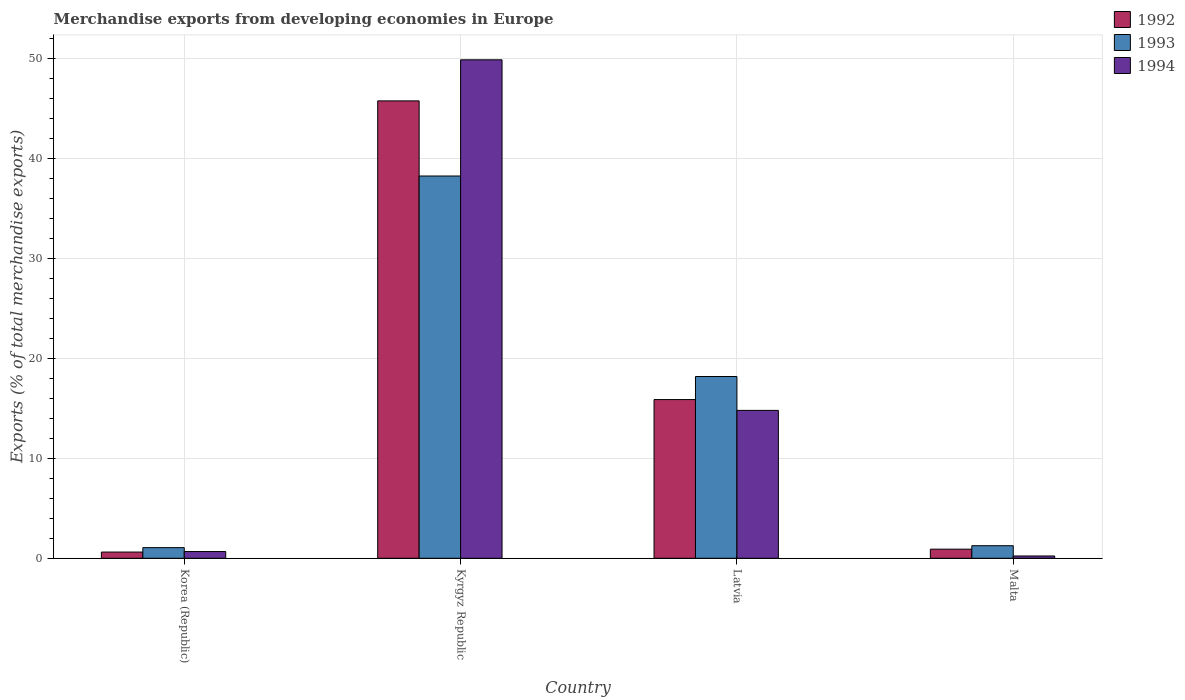How many groups of bars are there?
Make the answer very short. 4. How many bars are there on the 1st tick from the right?
Your answer should be very brief. 3. What is the label of the 4th group of bars from the left?
Offer a very short reply. Malta. In how many cases, is the number of bars for a given country not equal to the number of legend labels?
Your response must be concise. 0. What is the percentage of total merchandise exports in 1992 in Malta?
Keep it short and to the point. 0.91. Across all countries, what is the maximum percentage of total merchandise exports in 1992?
Make the answer very short. 45.73. Across all countries, what is the minimum percentage of total merchandise exports in 1993?
Your answer should be compact. 1.06. In which country was the percentage of total merchandise exports in 1994 maximum?
Make the answer very short. Kyrgyz Republic. What is the total percentage of total merchandise exports in 1994 in the graph?
Provide a short and direct response. 65.52. What is the difference between the percentage of total merchandise exports in 1993 in Kyrgyz Republic and that in Latvia?
Your answer should be compact. 20.04. What is the difference between the percentage of total merchandise exports in 1992 in Kyrgyz Republic and the percentage of total merchandise exports in 1994 in Latvia?
Ensure brevity in your answer.  30.94. What is the average percentage of total merchandise exports in 1994 per country?
Provide a short and direct response. 16.38. What is the difference between the percentage of total merchandise exports of/in 1993 and percentage of total merchandise exports of/in 1992 in Latvia?
Keep it short and to the point. 2.31. What is the ratio of the percentage of total merchandise exports in 1994 in Kyrgyz Republic to that in Malta?
Your answer should be very brief. 217.01. Is the difference between the percentage of total merchandise exports in 1993 in Korea (Republic) and Kyrgyz Republic greater than the difference between the percentage of total merchandise exports in 1992 in Korea (Republic) and Kyrgyz Republic?
Ensure brevity in your answer.  Yes. What is the difference between the highest and the second highest percentage of total merchandise exports in 1992?
Keep it short and to the point. -44.82. What is the difference between the highest and the lowest percentage of total merchandise exports in 1993?
Ensure brevity in your answer.  37.16. In how many countries, is the percentage of total merchandise exports in 1994 greater than the average percentage of total merchandise exports in 1994 taken over all countries?
Your answer should be very brief. 1. Is the sum of the percentage of total merchandise exports in 1993 in Korea (Republic) and Malta greater than the maximum percentage of total merchandise exports in 1992 across all countries?
Provide a short and direct response. No. What does the 1st bar from the left in Kyrgyz Republic represents?
Your response must be concise. 1992. Does the graph contain any zero values?
Offer a terse response. No. Where does the legend appear in the graph?
Keep it short and to the point. Top right. How are the legend labels stacked?
Offer a very short reply. Vertical. What is the title of the graph?
Offer a terse response. Merchandise exports from developing economies in Europe. What is the label or title of the Y-axis?
Provide a succinct answer. Exports (% of total merchandise exports). What is the Exports (% of total merchandise exports) of 1992 in Korea (Republic)?
Provide a succinct answer. 0.62. What is the Exports (% of total merchandise exports) of 1993 in Korea (Republic)?
Make the answer very short. 1.06. What is the Exports (% of total merchandise exports) in 1994 in Korea (Republic)?
Make the answer very short. 0.67. What is the Exports (% of total merchandise exports) in 1992 in Kyrgyz Republic?
Provide a short and direct response. 45.73. What is the Exports (% of total merchandise exports) of 1993 in Kyrgyz Republic?
Your answer should be compact. 38.22. What is the Exports (% of total merchandise exports) in 1994 in Kyrgyz Republic?
Your response must be concise. 49.84. What is the Exports (% of total merchandise exports) in 1992 in Latvia?
Provide a succinct answer. 15.87. What is the Exports (% of total merchandise exports) in 1993 in Latvia?
Give a very brief answer. 18.17. What is the Exports (% of total merchandise exports) of 1994 in Latvia?
Ensure brevity in your answer.  14.79. What is the Exports (% of total merchandise exports) of 1992 in Malta?
Your answer should be compact. 0.91. What is the Exports (% of total merchandise exports) of 1993 in Malta?
Your answer should be compact. 1.26. What is the Exports (% of total merchandise exports) in 1994 in Malta?
Provide a succinct answer. 0.23. Across all countries, what is the maximum Exports (% of total merchandise exports) in 1992?
Offer a very short reply. 45.73. Across all countries, what is the maximum Exports (% of total merchandise exports) in 1993?
Offer a very short reply. 38.22. Across all countries, what is the maximum Exports (% of total merchandise exports) of 1994?
Offer a terse response. 49.84. Across all countries, what is the minimum Exports (% of total merchandise exports) in 1992?
Ensure brevity in your answer.  0.62. Across all countries, what is the minimum Exports (% of total merchandise exports) in 1993?
Make the answer very short. 1.06. Across all countries, what is the minimum Exports (% of total merchandise exports) of 1994?
Offer a very short reply. 0.23. What is the total Exports (% of total merchandise exports) of 1992 in the graph?
Your answer should be compact. 63.13. What is the total Exports (% of total merchandise exports) in 1993 in the graph?
Your response must be concise. 58.71. What is the total Exports (% of total merchandise exports) of 1994 in the graph?
Keep it short and to the point. 65.52. What is the difference between the Exports (% of total merchandise exports) in 1992 in Korea (Republic) and that in Kyrgyz Republic?
Your answer should be very brief. -45.11. What is the difference between the Exports (% of total merchandise exports) of 1993 in Korea (Republic) and that in Kyrgyz Republic?
Ensure brevity in your answer.  -37.16. What is the difference between the Exports (% of total merchandise exports) of 1994 in Korea (Republic) and that in Kyrgyz Republic?
Give a very brief answer. -49.16. What is the difference between the Exports (% of total merchandise exports) in 1992 in Korea (Republic) and that in Latvia?
Your response must be concise. -15.25. What is the difference between the Exports (% of total merchandise exports) in 1993 in Korea (Republic) and that in Latvia?
Provide a short and direct response. -17.11. What is the difference between the Exports (% of total merchandise exports) of 1994 in Korea (Republic) and that in Latvia?
Ensure brevity in your answer.  -14.11. What is the difference between the Exports (% of total merchandise exports) in 1992 in Korea (Republic) and that in Malta?
Provide a short and direct response. -0.29. What is the difference between the Exports (% of total merchandise exports) of 1993 in Korea (Republic) and that in Malta?
Offer a terse response. -0.19. What is the difference between the Exports (% of total merchandise exports) of 1994 in Korea (Republic) and that in Malta?
Keep it short and to the point. 0.44. What is the difference between the Exports (% of total merchandise exports) of 1992 in Kyrgyz Republic and that in Latvia?
Offer a terse response. 29.86. What is the difference between the Exports (% of total merchandise exports) of 1993 in Kyrgyz Republic and that in Latvia?
Ensure brevity in your answer.  20.04. What is the difference between the Exports (% of total merchandise exports) in 1994 in Kyrgyz Republic and that in Latvia?
Keep it short and to the point. 35.05. What is the difference between the Exports (% of total merchandise exports) of 1992 in Kyrgyz Republic and that in Malta?
Your answer should be compact. 44.82. What is the difference between the Exports (% of total merchandise exports) of 1993 in Kyrgyz Republic and that in Malta?
Offer a very short reply. 36.96. What is the difference between the Exports (% of total merchandise exports) in 1994 in Kyrgyz Republic and that in Malta?
Your answer should be compact. 49.61. What is the difference between the Exports (% of total merchandise exports) in 1992 in Latvia and that in Malta?
Keep it short and to the point. 14.96. What is the difference between the Exports (% of total merchandise exports) in 1993 in Latvia and that in Malta?
Your response must be concise. 16.92. What is the difference between the Exports (% of total merchandise exports) in 1994 in Latvia and that in Malta?
Keep it short and to the point. 14.56. What is the difference between the Exports (% of total merchandise exports) in 1992 in Korea (Republic) and the Exports (% of total merchandise exports) in 1993 in Kyrgyz Republic?
Keep it short and to the point. -37.6. What is the difference between the Exports (% of total merchandise exports) of 1992 in Korea (Republic) and the Exports (% of total merchandise exports) of 1994 in Kyrgyz Republic?
Your answer should be compact. -49.22. What is the difference between the Exports (% of total merchandise exports) in 1993 in Korea (Republic) and the Exports (% of total merchandise exports) in 1994 in Kyrgyz Republic?
Offer a terse response. -48.77. What is the difference between the Exports (% of total merchandise exports) of 1992 in Korea (Republic) and the Exports (% of total merchandise exports) of 1993 in Latvia?
Provide a succinct answer. -17.55. What is the difference between the Exports (% of total merchandise exports) of 1992 in Korea (Republic) and the Exports (% of total merchandise exports) of 1994 in Latvia?
Keep it short and to the point. -14.16. What is the difference between the Exports (% of total merchandise exports) of 1993 in Korea (Republic) and the Exports (% of total merchandise exports) of 1994 in Latvia?
Your answer should be compact. -13.72. What is the difference between the Exports (% of total merchandise exports) in 1992 in Korea (Republic) and the Exports (% of total merchandise exports) in 1993 in Malta?
Provide a short and direct response. -0.63. What is the difference between the Exports (% of total merchandise exports) in 1992 in Korea (Republic) and the Exports (% of total merchandise exports) in 1994 in Malta?
Your answer should be very brief. 0.39. What is the difference between the Exports (% of total merchandise exports) in 1993 in Korea (Republic) and the Exports (% of total merchandise exports) in 1994 in Malta?
Provide a succinct answer. 0.83. What is the difference between the Exports (% of total merchandise exports) of 1992 in Kyrgyz Republic and the Exports (% of total merchandise exports) of 1993 in Latvia?
Your answer should be compact. 27.56. What is the difference between the Exports (% of total merchandise exports) in 1992 in Kyrgyz Republic and the Exports (% of total merchandise exports) in 1994 in Latvia?
Offer a terse response. 30.94. What is the difference between the Exports (% of total merchandise exports) in 1993 in Kyrgyz Republic and the Exports (% of total merchandise exports) in 1994 in Latvia?
Give a very brief answer. 23.43. What is the difference between the Exports (% of total merchandise exports) of 1992 in Kyrgyz Republic and the Exports (% of total merchandise exports) of 1993 in Malta?
Give a very brief answer. 44.47. What is the difference between the Exports (% of total merchandise exports) in 1992 in Kyrgyz Republic and the Exports (% of total merchandise exports) in 1994 in Malta?
Make the answer very short. 45.5. What is the difference between the Exports (% of total merchandise exports) of 1993 in Kyrgyz Republic and the Exports (% of total merchandise exports) of 1994 in Malta?
Make the answer very short. 37.99. What is the difference between the Exports (% of total merchandise exports) in 1992 in Latvia and the Exports (% of total merchandise exports) in 1993 in Malta?
Give a very brief answer. 14.61. What is the difference between the Exports (% of total merchandise exports) in 1992 in Latvia and the Exports (% of total merchandise exports) in 1994 in Malta?
Your response must be concise. 15.64. What is the difference between the Exports (% of total merchandise exports) in 1993 in Latvia and the Exports (% of total merchandise exports) in 1994 in Malta?
Your answer should be compact. 17.94. What is the average Exports (% of total merchandise exports) of 1992 per country?
Provide a succinct answer. 15.78. What is the average Exports (% of total merchandise exports) in 1993 per country?
Your answer should be compact. 14.68. What is the average Exports (% of total merchandise exports) in 1994 per country?
Provide a succinct answer. 16.38. What is the difference between the Exports (% of total merchandise exports) of 1992 and Exports (% of total merchandise exports) of 1993 in Korea (Republic)?
Give a very brief answer. -0.44. What is the difference between the Exports (% of total merchandise exports) in 1992 and Exports (% of total merchandise exports) in 1994 in Korea (Republic)?
Provide a short and direct response. -0.05. What is the difference between the Exports (% of total merchandise exports) in 1993 and Exports (% of total merchandise exports) in 1994 in Korea (Republic)?
Make the answer very short. 0.39. What is the difference between the Exports (% of total merchandise exports) of 1992 and Exports (% of total merchandise exports) of 1993 in Kyrgyz Republic?
Your answer should be compact. 7.51. What is the difference between the Exports (% of total merchandise exports) in 1992 and Exports (% of total merchandise exports) in 1994 in Kyrgyz Republic?
Provide a succinct answer. -4.11. What is the difference between the Exports (% of total merchandise exports) of 1993 and Exports (% of total merchandise exports) of 1994 in Kyrgyz Republic?
Your answer should be very brief. -11.62. What is the difference between the Exports (% of total merchandise exports) of 1992 and Exports (% of total merchandise exports) of 1993 in Latvia?
Provide a succinct answer. -2.31. What is the difference between the Exports (% of total merchandise exports) in 1992 and Exports (% of total merchandise exports) in 1994 in Latvia?
Your response must be concise. 1.08. What is the difference between the Exports (% of total merchandise exports) of 1993 and Exports (% of total merchandise exports) of 1994 in Latvia?
Make the answer very short. 3.39. What is the difference between the Exports (% of total merchandise exports) in 1992 and Exports (% of total merchandise exports) in 1993 in Malta?
Make the answer very short. -0.34. What is the difference between the Exports (% of total merchandise exports) of 1992 and Exports (% of total merchandise exports) of 1994 in Malta?
Make the answer very short. 0.68. What is the difference between the Exports (% of total merchandise exports) of 1993 and Exports (% of total merchandise exports) of 1994 in Malta?
Your answer should be very brief. 1.03. What is the ratio of the Exports (% of total merchandise exports) in 1992 in Korea (Republic) to that in Kyrgyz Republic?
Give a very brief answer. 0.01. What is the ratio of the Exports (% of total merchandise exports) in 1993 in Korea (Republic) to that in Kyrgyz Republic?
Keep it short and to the point. 0.03. What is the ratio of the Exports (% of total merchandise exports) of 1994 in Korea (Republic) to that in Kyrgyz Republic?
Your response must be concise. 0.01. What is the ratio of the Exports (% of total merchandise exports) in 1992 in Korea (Republic) to that in Latvia?
Your answer should be very brief. 0.04. What is the ratio of the Exports (% of total merchandise exports) in 1993 in Korea (Republic) to that in Latvia?
Your answer should be compact. 0.06. What is the ratio of the Exports (% of total merchandise exports) in 1994 in Korea (Republic) to that in Latvia?
Offer a very short reply. 0.05. What is the ratio of the Exports (% of total merchandise exports) of 1992 in Korea (Republic) to that in Malta?
Ensure brevity in your answer.  0.68. What is the ratio of the Exports (% of total merchandise exports) of 1993 in Korea (Republic) to that in Malta?
Make the answer very short. 0.85. What is the ratio of the Exports (% of total merchandise exports) in 1994 in Korea (Republic) to that in Malta?
Offer a very short reply. 2.93. What is the ratio of the Exports (% of total merchandise exports) of 1992 in Kyrgyz Republic to that in Latvia?
Make the answer very short. 2.88. What is the ratio of the Exports (% of total merchandise exports) in 1993 in Kyrgyz Republic to that in Latvia?
Your answer should be compact. 2.1. What is the ratio of the Exports (% of total merchandise exports) in 1994 in Kyrgyz Republic to that in Latvia?
Make the answer very short. 3.37. What is the ratio of the Exports (% of total merchandise exports) in 1992 in Kyrgyz Republic to that in Malta?
Provide a short and direct response. 50.24. What is the ratio of the Exports (% of total merchandise exports) of 1993 in Kyrgyz Republic to that in Malta?
Your response must be concise. 30.45. What is the ratio of the Exports (% of total merchandise exports) of 1994 in Kyrgyz Republic to that in Malta?
Ensure brevity in your answer.  217.01. What is the ratio of the Exports (% of total merchandise exports) of 1992 in Latvia to that in Malta?
Offer a very short reply. 17.43. What is the ratio of the Exports (% of total merchandise exports) of 1993 in Latvia to that in Malta?
Your answer should be very brief. 14.48. What is the ratio of the Exports (% of total merchandise exports) of 1994 in Latvia to that in Malta?
Offer a very short reply. 64.38. What is the difference between the highest and the second highest Exports (% of total merchandise exports) of 1992?
Ensure brevity in your answer.  29.86. What is the difference between the highest and the second highest Exports (% of total merchandise exports) in 1993?
Make the answer very short. 20.04. What is the difference between the highest and the second highest Exports (% of total merchandise exports) in 1994?
Your response must be concise. 35.05. What is the difference between the highest and the lowest Exports (% of total merchandise exports) of 1992?
Ensure brevity in your answer.  45.11. What is the difference between the highest and the lowest Exports (% of total merchandise exports) in 1993?
Your answer should be compact. 37.16. What is the difference between the highest and the lowest Exports (% of total merchandise exports) in 1994?
Offer a terse response. 49.61. 